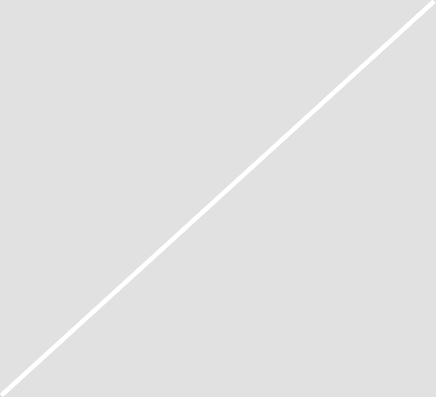<chart> <loc_0><loc_0><loc_500><loc_500><pie_chart><fcel>For the three months ended<nl><fcel>100.0%<nl></chart> 